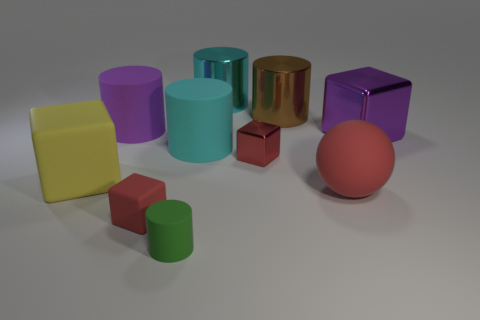What is the shape of the small red object that is made of the same material as the large ball?
Offer a terse response. Cube. Are there more small yellow rubber balls than large red balls?
Make the answer very short. No. There is a large purple rubber thing; is its shape the same as the tiny matte object behind the small green object?
Provide a succinct answer. No. What is the material of the ball?
Provide a short and direct response. Rubber. What is the color of the block in front of the red matte ball in front of the large purple thing that is on the left side of the big purple metallic cube?
Keep it short and to the point. Red. There is a large brown thing that is the same shape as the small green rubber thing; what is its material?
Give a very brief answer. Metal. How many spheres are the same size as the cyan shiny thing?
Ensure brevity in your answer.  1. How many purple things are there?
Provide a short and direct response. 2. Does the large yellow object have the same material as the small red cube on the left side of the tiny shiny cube?
Offer a terse response. Yes. How many cyan objects are either metal things or things?
Provide a succinct answer. 2. 